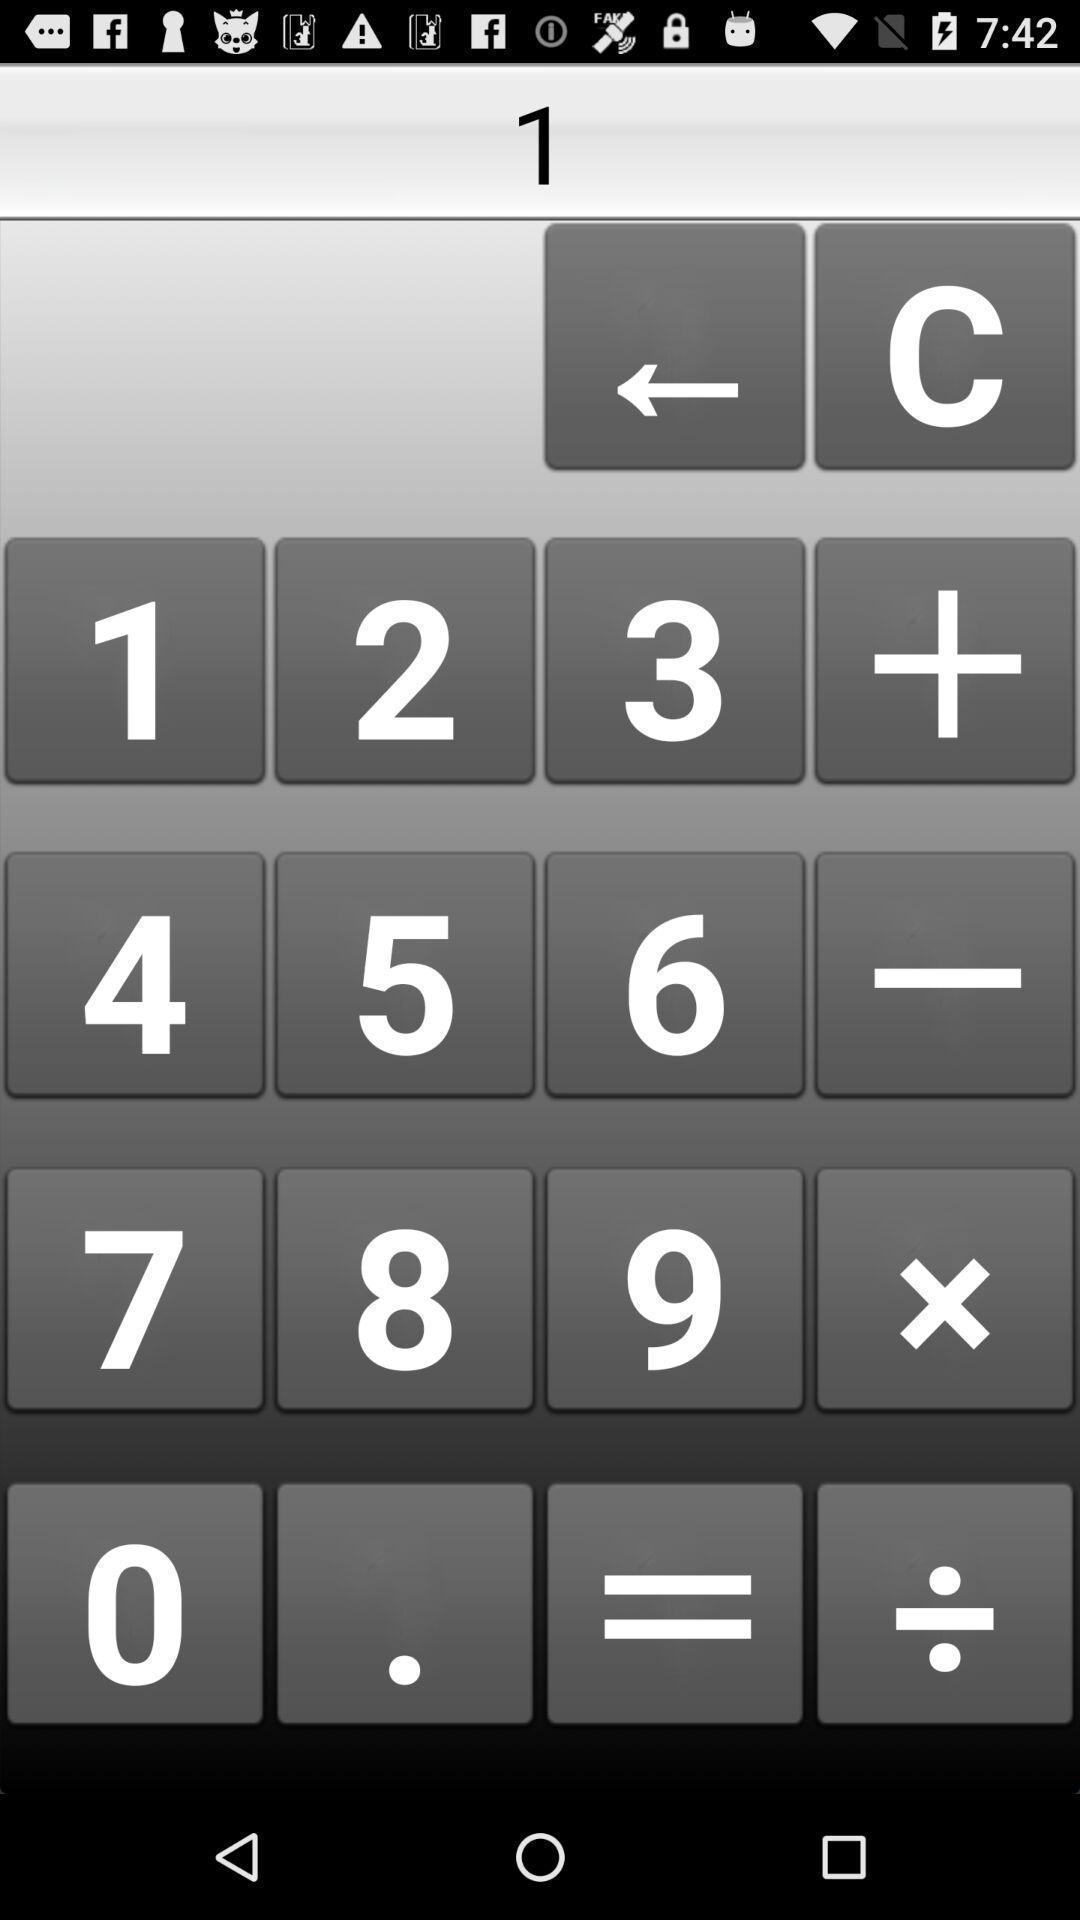Explain what's happening in this screen capture. Page displaying the values of the calculator. 